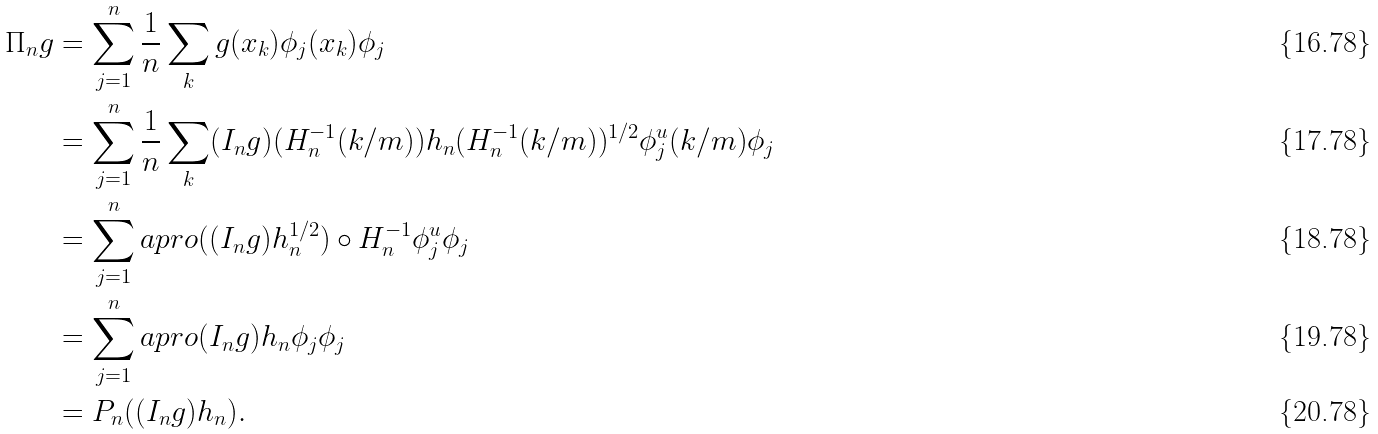<formula> <loc_0><loc_0><loc_500><loc_500>\Pi _ { n } g & = \sum _ { j = 1 } ^ { n } \frac { 1 } { n } \sum _ { k } g ( x _ { k } ) \phi _ { j } ( x _ { k } ) \phi _ { j } \\ & = \sum _ { j = 1 } ^ { n } \frac { 1 } { n } \sum _ { k } ( I _ { n } g ) ( H _ { n } ^ { - 1 } ( k / m ) ) h _ { n } ( H _ { n } ^ { - 1 } ( k / m ) ) ^ { 1 / 2 } \phi _ { j } ^ { u } ( k / m ) \phi _ { j } \\ & = \sum _ { j = 1 } ^ { n } a p r o { ( ( I _ { n } g ) h _ { n } ^ { 1 / 2 } ) \circ H _ { n } ^ { - 1 } } { \phi _ { j } ^ { u } } \phi _ { j } \\ & = \sum _ { j = 1 } ^ { n } a p r o { ( I _ { n } g ) h _ { n } } { \phi _ { j } } \phi _ { j } \\ & = P _ { n } ( ( I _ { n } g ) h _ { n } ) .</formula> 